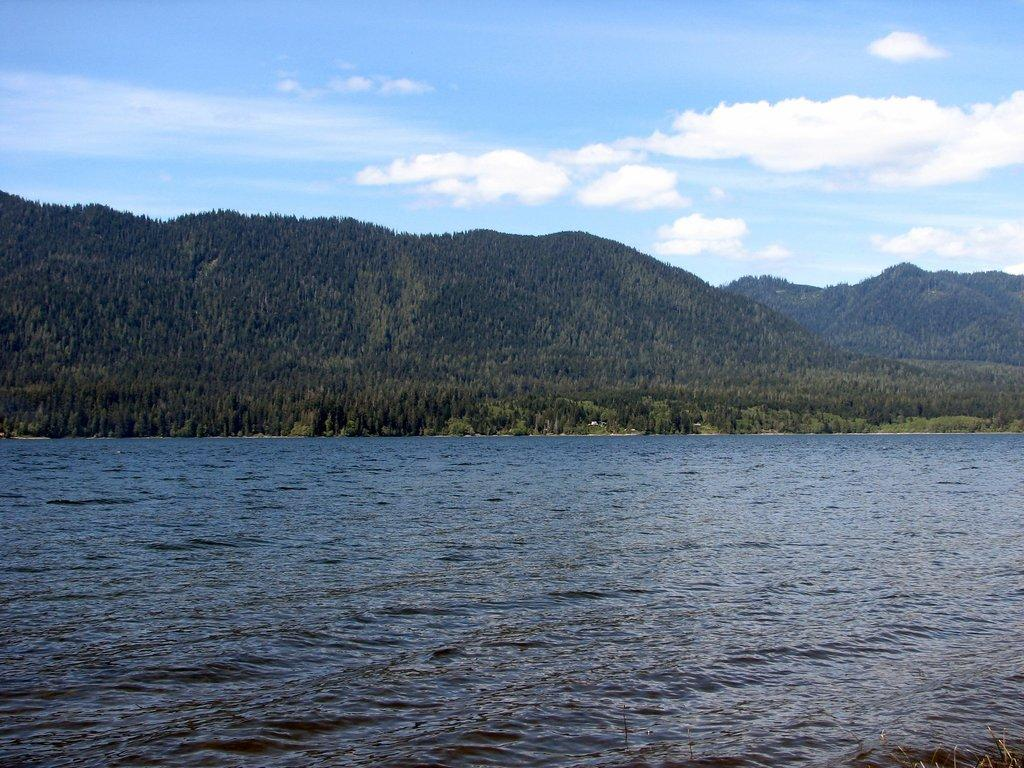What is the primary element visible in the image? There is water in the image. What can be seen in the distance behind the water? There are hills in the background of the image, with trees present on them. What is visible above the hills and water? The sky is visible in the image, with clouds present. Where is the zoo located in the image? There is no zoo present in the image. What type of chain can be seen connecting the clouds in the image? There is no chain connecting the clouds in the image; the clouds are not connected. 